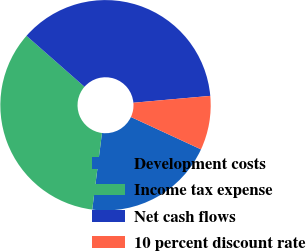Convert chart. <chart><loc_0><loc_0><loc_500><loc_500><pie_chart><fcel>Development costs<fcel>Income tax expense<fcel>Net cash flows<fcel>10 percent discount rate<nl><fcel>20.13%<fcel>34.46%<fcel>37.11%<fcel>8.31%<nl></chart> 